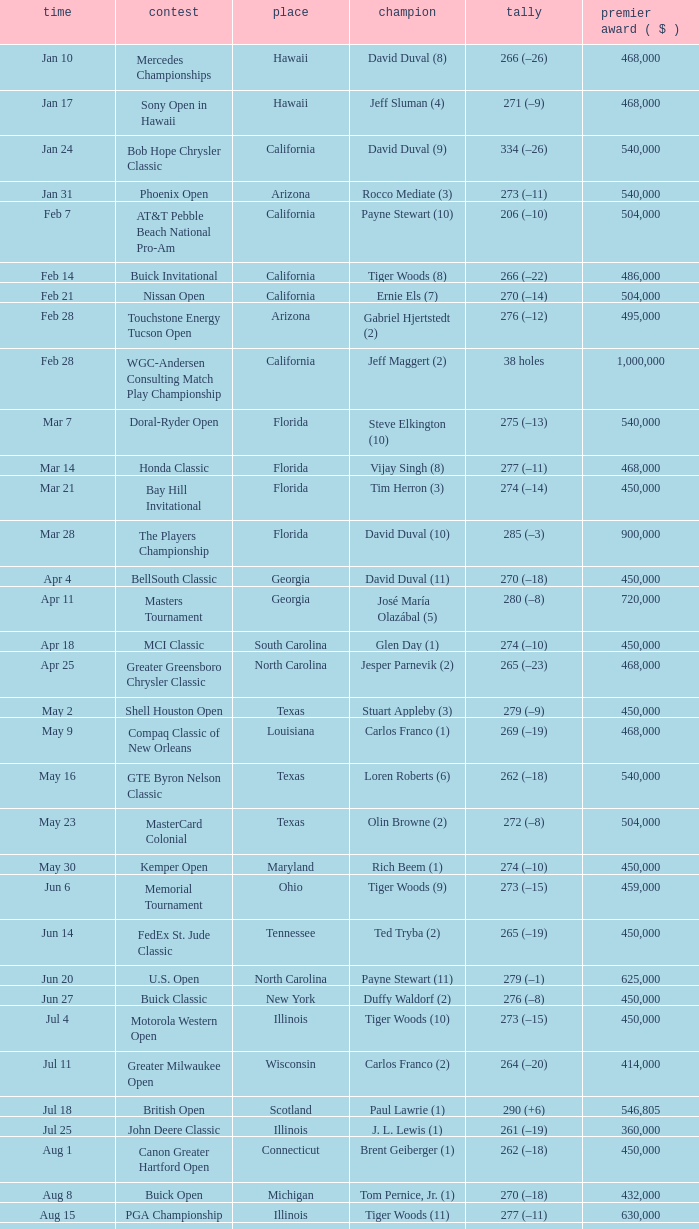What is the date of the Greater Greensboro Chrysler Classic? Apr 25. Help me parse the entirety of this table. {'header': ['time', 'contest', 'place', 'champion', 'tally', 'premier award ( $ )'], 'rows': [['Jan 10', 'Mercedes Championships', 'Hawaii', 'David Duval (8)', '266 (–26)', '468,000'], ['Jan 17', 'Sony Open in Hawaii', 'Hawaii', 'Jeff Sluman (4)', '271 (–9)', '468,000'], ['Jan 24', 'Bob Hope Chrysler Classic', 'California', 'David Duval (9)', '334 (–26)', '540,000'], ['Jan 31', 'Phoenix Open', 'Arizona', 'Rocco Mediate (3)', '273 (–11)', '540,000'], ['Feb 7', 'AT&T Pebble Beach National Pro-Am', 'California', 'Payne Stewart (10)', '206 (–10)', '504,000'], ['Feb 14', 'Buick Invitational', 'California', 'Tiger Woods (8)', '266 (–22)', '486,000'], ['Feb 21', 'Nissan Open', 'California', 'Ernie Els (7)', '270 (–14)', '504,000'], ['Feb 28', 'Touchstone Energy Tucson Open', 'Arizona', 'Gabriel Hjertstedt (2)', '276 (–12)', '495,000'], ['Feb 28', 'WGC-Andersen Consulting Match Play Championship', 'California', 'Jeff Maggert (2)', '38 holes', '1,000,000'], ['Mar 7', 'Doral-Ryder Open', 'Florida', 'Steve Elkington (10)', '275 (–13)', '540,000'], ['Mar 14', 'Honda Classic', 'Florida', 'Vijay Singh (8)', '277 (–11)', '468,000'], ['Mar 21', 'Bay Hill Invitational', 'Florida', 'Tim Herron (3)', '274 (–14)', '450,000'], ['Mar 28', 'The Players Championship', 'Florida', 'David Duval (10)', '285 (–3)', '900,000'], ['Apr 4', 'BellSouth Classic', 'Georgia', 'David Duval (11)', '270 (–18)', '450,000'], ['Apr 11', 'Masters Tournament', 'Georgia', 'José María Olazábal (5)', '280 (–8)', '720,000'], ['Apr 18', 'MCI Classic', 'South Carolina', 'Glen Day (1)', '274 (–10)', '450,000'], ['Apr 25', 'Greater Greensboro Chrysler Classic', 'North Carolina', 'Jesper Parnevik (2)', '265 (–23)', '468,000'], ['May 2', 'Shell Houston Open', 'Texas', 'Stuart Appleby (3)', '279 (–9)', '450,000'], ['May 9', 'Compaq Classic of New Orleans', 'Louisiana', 'Carlos Franco (1)', '269 (–19)', '468,000'], ['May 16', 'GTE Byron Nelson Classic', 'Texas', 'Loren Roberts (6)', '262 (–18)', '540,000'], ['May 23', 'MasterCard Colonial', 'Texas', 'Olin Browne (2)', '272 (–8)', '504,000'], ['May 30', 'Kemper Open', 'Maryland', 'Rich Beem (1)', '274 (–10)', '450,000'], ['Jun 6', 'Memorial Tournament', 'Ohio', 'Tiger Woods (9)', '273 (–15)', '459,000'], ['Jun 14', 'FedEx St. Jude Classic', 'Tennessee', 'Ted Tryba (2)', '265 (–19)', '450,000'], ['Jun 20', 'U.S. Open', 'North Carolina', 'Payne Stewart (11)', '279 (–1)', '625,000'], ['Jun 27', 'Buick Classic', 'New York', 'Duffy Waldorf (2)', '276 (–8)', '450,000'], ['Jul 4', 'Motorola Western Open', 'Illinois', 'Tiger Woods (10)', '273 (–15)', '450,000'], ['Jul 11', 'Greater Milwaukee Open', 'Wisconsin', 'Carlos Franco (2)', '264 (–20)', '414,000'], ['Jul 18', 'British Open', 'Scotland', 'Paul Lawrie (1)', '290 (+6)', '546,805'], ['Jul 25', 'John Deere Classic', 'Illinois', 'J. L. Lewis (1)', '261 (–19)', '360,000'], ['Aug 1', 'Canon Greater Hartford Open', 'Connecticut', 'Brent Geiberger (1)', '262 (–18)', '450,000'], ['Aug 8', 'Buick Open', 'Michigan', 'Tom Pernice, Jr. (1)', '270 (–18)', '432,000'], ['Aug 15', 'PGA Championship', 'Illinois', 'Tiger Woods (11)', '277 (–11)', '630,000'], ['Aug 22', 'Sprint International', 'Colorado', 'David Toms (2)', '47 ( Stableford )', '468,000'], ['Aug 29', 'Reno-Tahoe Open', 'Nevada', 'Notah Begay III (1)', '274 (–14)', '495,000'], ['Aug 29', 'WGC-NEC Invitational', 'Ohio', 'Tiger Woods (12)', '270 (–10)', '1,000,000'], ['Sep 5', 'Air Canada Championship', 'Canada', 'Mike Weir (1)', '266 (–18)', '450,000'], ['Sep 12', 'Bell Canadian Open', 'Canada', 'Hal Sutton (11)', '275 (–13)', '450,000'], ['Sep 19', 'B.C. Open', 'New York', 'Brad Faxon (5)', '273 (–15)', '288,000'], ['Sep 26', 'Westin Texas Open', 'Texas', 'Duffy Waldorf (3)', '270 (–18)', '360,000'], ['Oct 3', 'Buick Challenge', 'Georgia', 'David Toms (3)', '271 (–17)', '324,000'], ['Oct 10', 'Michelob Championship at Kingsmill', 'Virginia', 'Notah Begay III (2)', '274 (–10)', '450,000'], ['Oct 17', 'Las Vegas Invitational', 'Nevada', 'Jim Furyk (4)', '331 (–29)', '450,000'], ['Oct 24', 'National Car Rental Golf Classic Disney', 'Florida', 'Tiger Woods (13)', '271 (–17)', '450,000'], ['Oct 31', 'The Tour Championship', 'Texas', 'Tiger Woods (14)', '269 (–15)', '900,000'], ['Nov 1', 'Southern Farm Bureau Classic', 'Mississippi', 'Brian Henninger (2)', '202 (–14)', '360,000'], ['Nov 7', 'WGC-American Express Championship', 'Spain', 'Tiger Woods (15)', '278 (–6)', '1,000,000']]} 